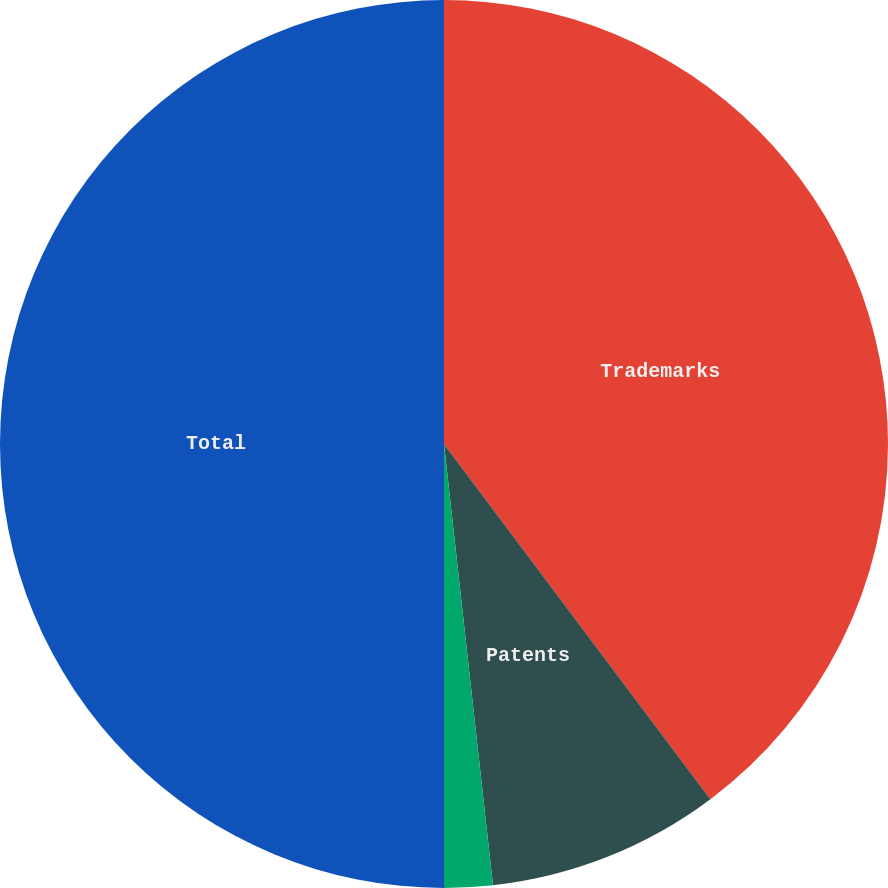Convert chart to OTSL. <chart><loc_0><loc_0><loc_500><loc_500><pie_chart><fcel>Trademarks<fcel>Patents<fcel>Other<fcel>Total<nl><fcel>39.76%<fcel>8.48%<fcel>1.76%<fcel>50.0%<nl></chart> 